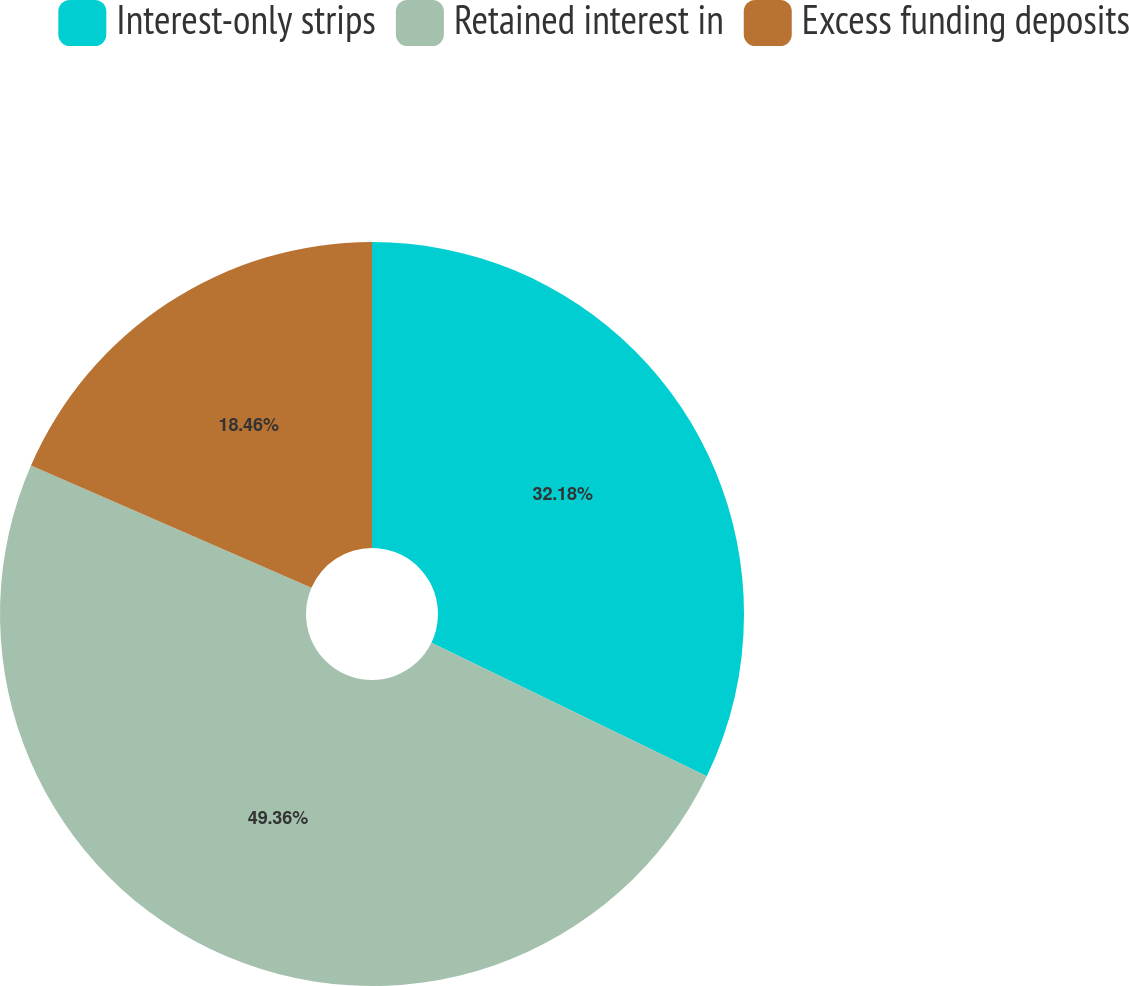Convert chart to OTSL. <chart><loc_0><loc_0><loc_500><loc_500><pie_chart><fcel>Interest-only strips<fcel>Retained interest in<fcel>Excess funding deposits<nl><fcel>32.18%<fcel>49.36%<fcel>18.46%<nl></chart> 